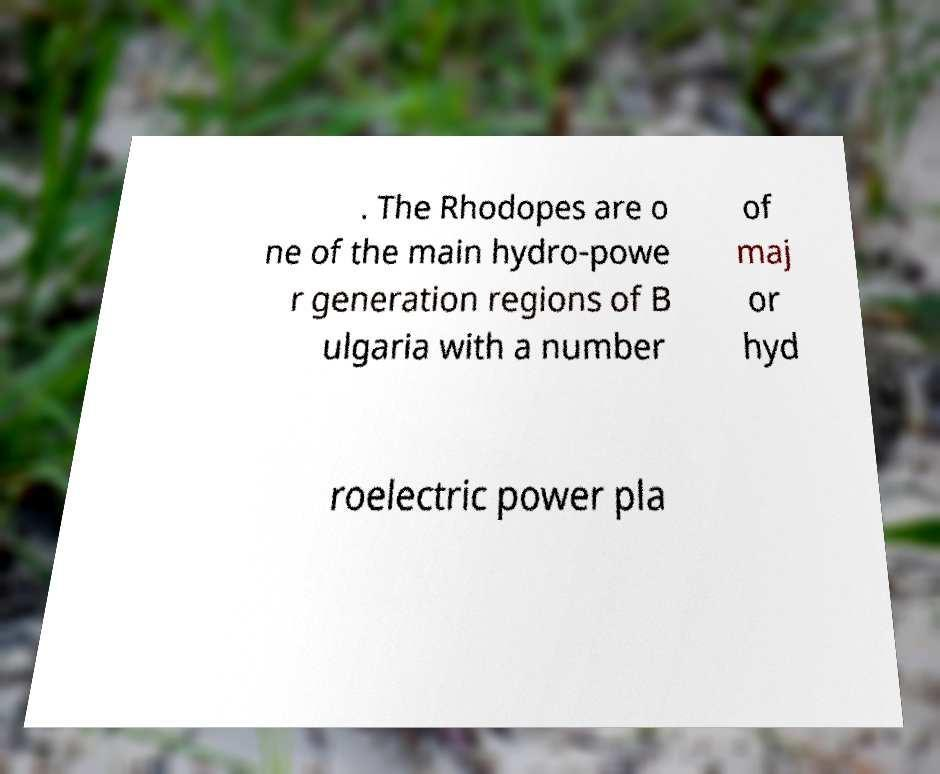What messages or text are displayed in this image? I need them in a readable, typed format. . The Rhodopes are o ne of the main hydro-powe r generation regions of B ulgaria with a number of maj or hyd roelectric power pla 